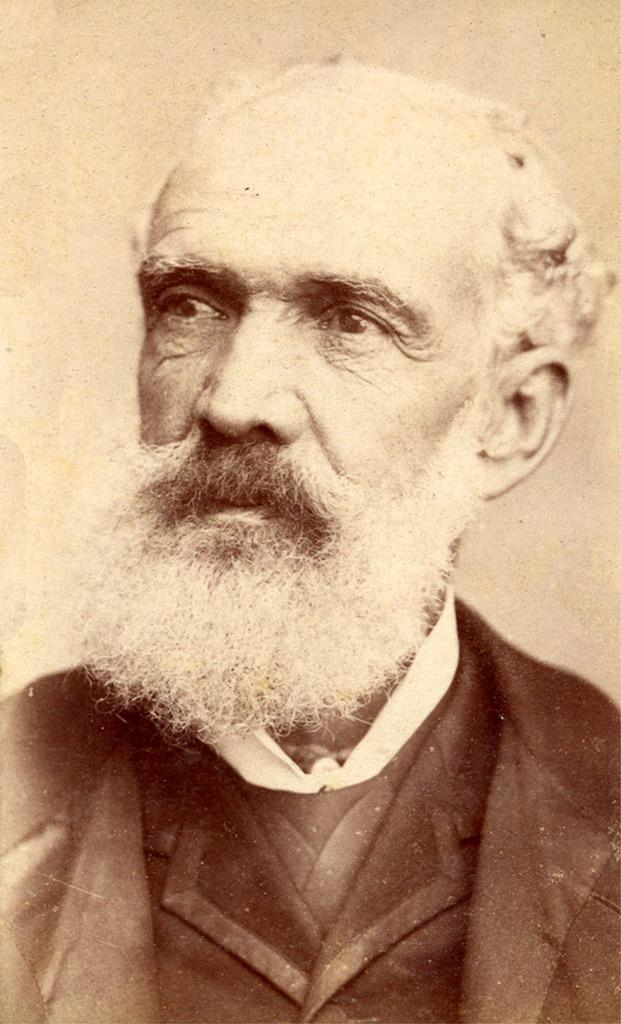What is the main subject of the image? There is a photo of a man in the image. Can you describe the man in the photo? Unfortunately, the provided facts do not include any details about the man's appearance or actions. Is there anything else in the image besides the photo of the man? The provided facts do not mention any other elements in the image. What type of flower is the man holding in the image? There is no flower present in the image, as the only subject mentioned is a photo of a man. 